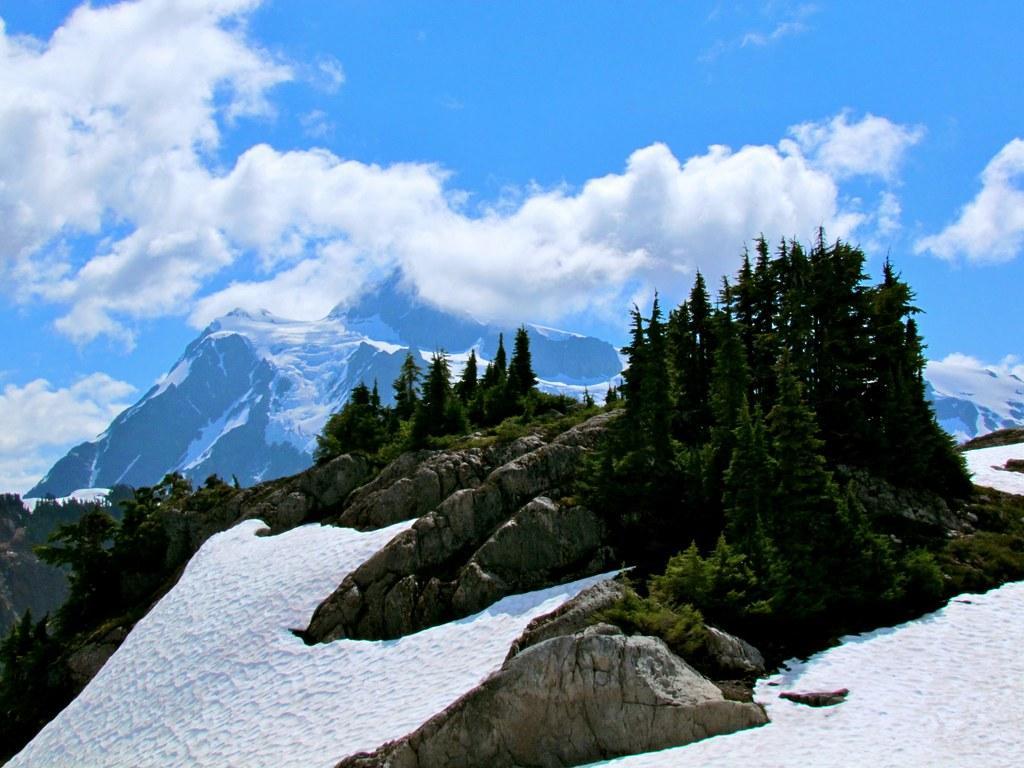Please provide a concise description of this image. In this image in front there are rocks, plants. At the bottom of the image there is snow on the surface. In the background of the image there are trees, mountains and sky. 